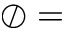<formula> <loc_0><loc_0><loc_500><loc_500>\oslash =</formula> 